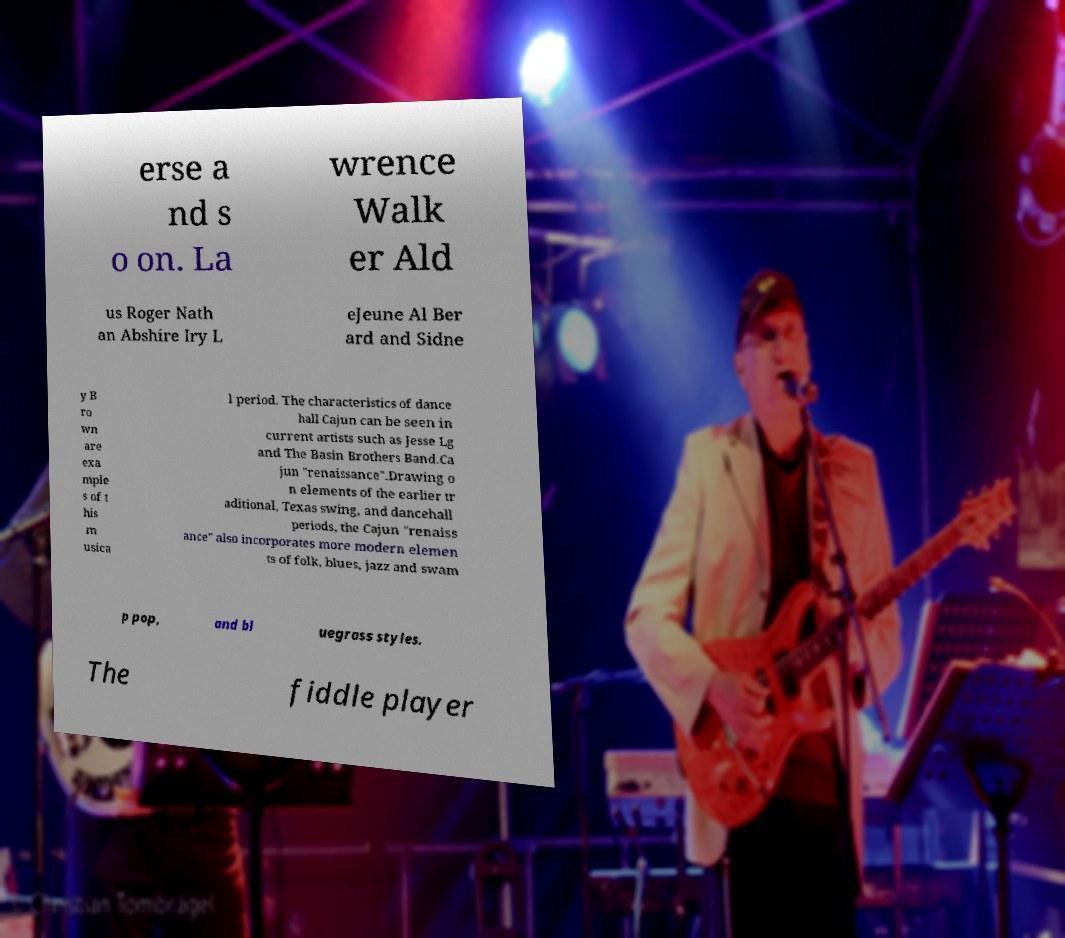What messages or text are displayed in this image? I need them in a readable, typed format. erse a nd s o on. La wrence Walk er Ald us Roger Nath an Abshire Iry L eJeune Al Ber ard and Sidne y B ro wn are exa mple s of t his m usica l period. The characteristics of dance hall Cajun can be seen in current artists such as Jesse Lg and The Basin Brothers Band.Ca jun "renaissance".Drawing o n elements of the earlier tr aditional, Texas swing, and dancehall periods, the Cajun "renaiss ance" also incorporates more modern elemen ts of folk, blues, jazz and swam p pop, and bl uegrass styles. The fiddle player 